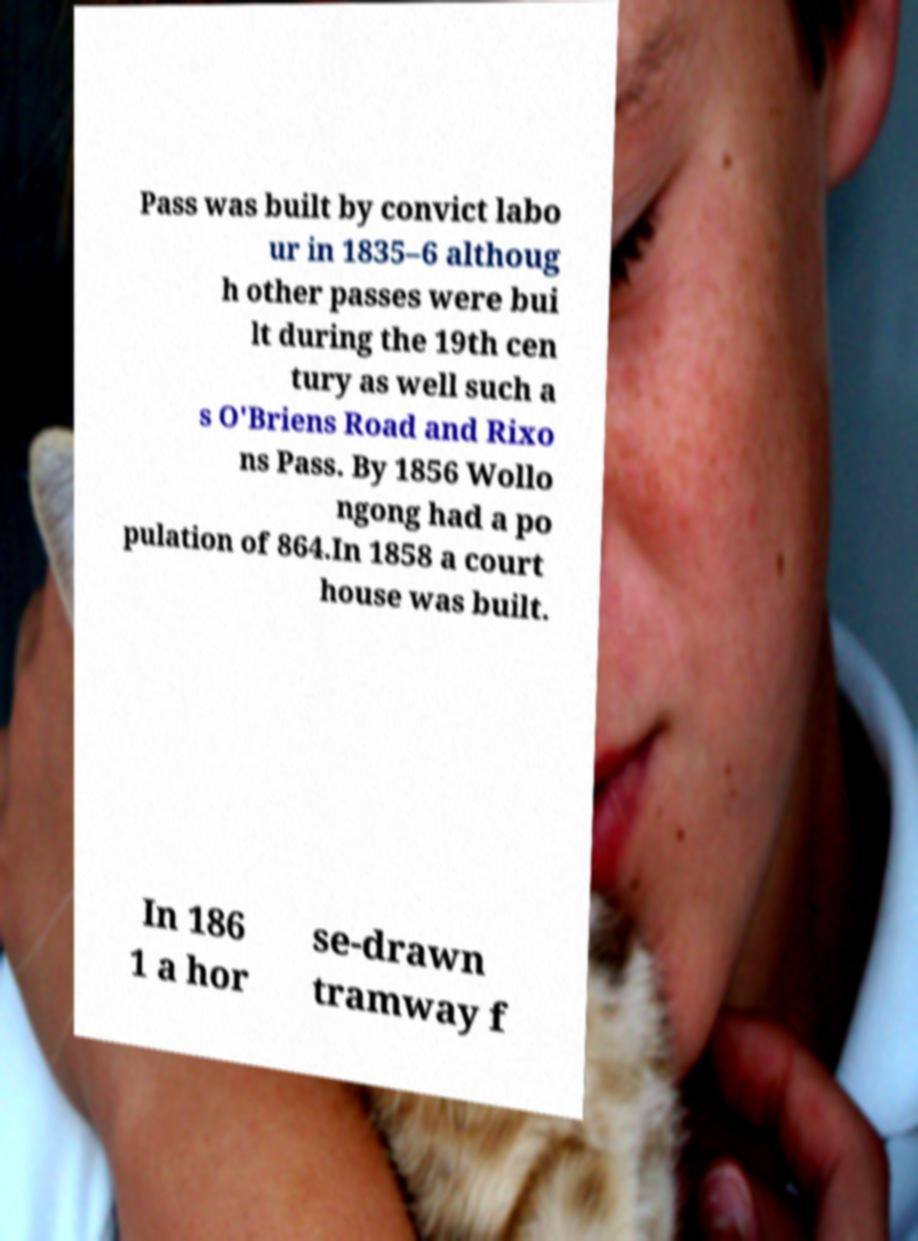There's text embedded in this image that I need extracted. Can you transcribe it verbatim? Pass was built by convict labo ur in 1835–6 althoug h other passes were bui lt during the 19th cen tury as well such a s O'Briens Road and Rixo ns Pass. By 1856 Wollo ngong had a po pulation of 864.In 1858 a court house was built. In 186 1 a hor se-drawn tramway f 